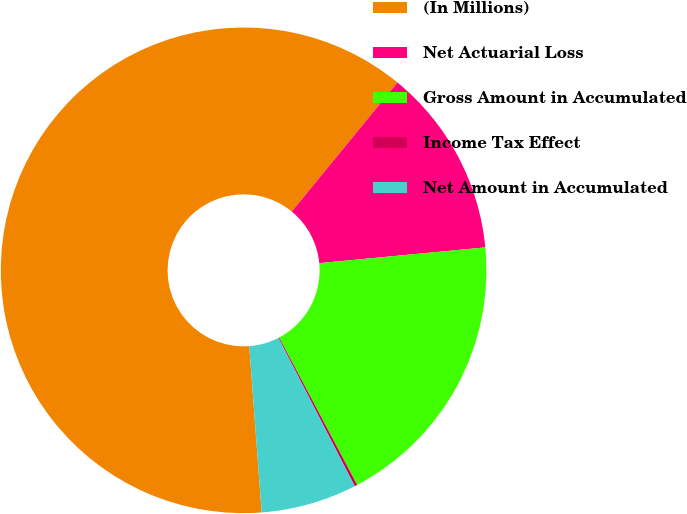Convert chart. <chart><loc_0><loc_0><loc_500><loc_500><pie_chart><fcel>(In Millions)<fcel>Net Actuarial Loss<fcel>Gross Amount in Accumulated<fcel>Income Tax Effect<fcel>Net Amount in Accumulated<nl><fcel>62.11%<fcel>12.57%<fcel>18.76%<fcel>0.18%<fcel>6.38%<nl></chart> 